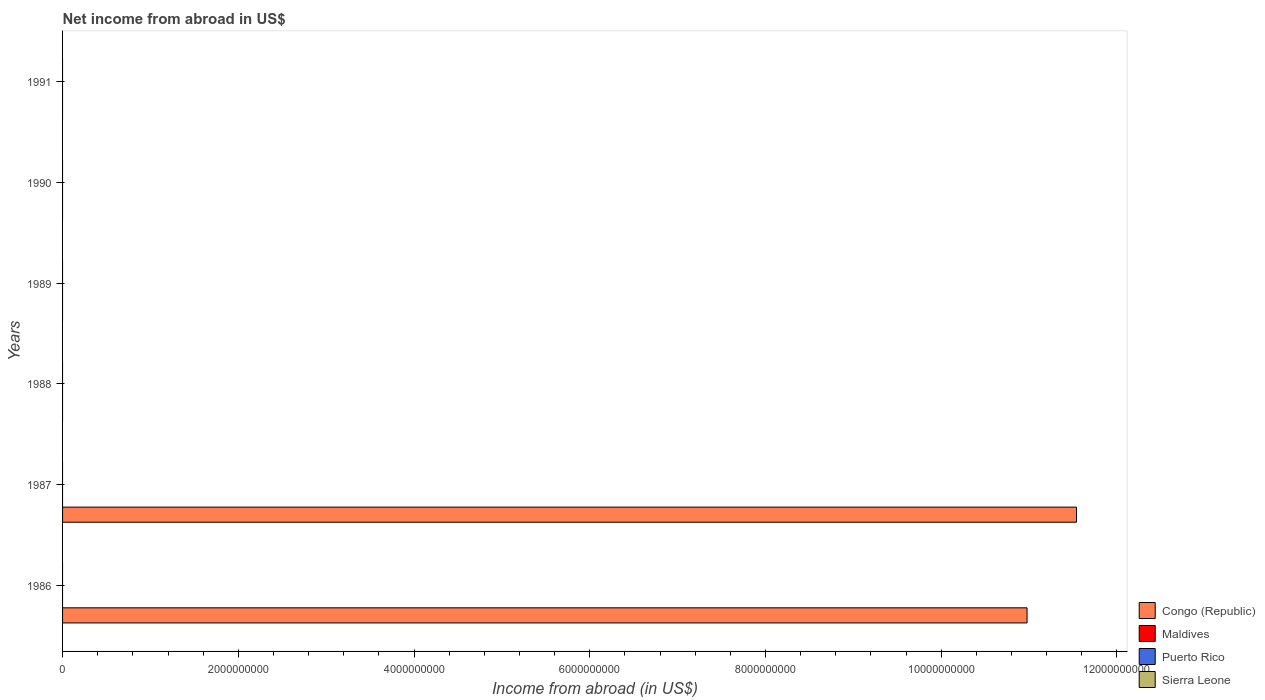Are the number of bars per tick equal to the number of legend labels?
Offer a very short reply. No. Are the number of bars on each tick of the Y-axis equal?
Make the answer very short. No. What is the label of the 5th group of bars from the top?
Provide a succinct answer. 1987. In how many cases, is the number of bars for a given year not equal to the number of legend labels?
Give a very brief answer. 6. Across all years, what is the maximum net income from abroad in Congo (Republic)?
Give a very brief answer. 1.15e+1. In which year was the net income from abroad in Congo (Republic) maximum?
Your response must be concise. 1987. What is the difference between the highest and the lowest net income from abroad in Congo (Republic)?
Keep it short and to the point. 1.15e+1. Is it the case that in every year, the sum of the net income from abroad in Puerto Rico and net income from abroad in Maldives is greater than the sum of net income from abroad in Congo (Republic) and net income from abroad in Sierra Leone?
Make the answer very short. No. Are the values on the major ticks of X-axis written in scientific E-notation?
Offer a very short reply. No. Does the graph contain any zero values?
Ensure brevity in your answer.  Yes. Does the graph contain grids?
Your answer should be compact. No. Where does the legend appear in the graph?
Your answer should be very brief. Bottom right. What is the title of the graph?
Give a very brief answer. Net income from abroad in US$. What is the label or title of the X-axis?
Give a very brief answer. Income from abroad (in US$). What is the Income from abroad (in US$) in Congo (Republic) in 1986?
Your response must be concise. 1.10e+1. What is the Income from abroad (in US$) of Puerto Rico in 1986?
Your response must be concise. 0. What is the Income from abroad (in US$) of Congo (Republic) in 1987?
Offer a terse response. 1.15e+1. What is the Income from abroad (in US$) in Sierra Leone in 1987?
Give a very brief answer. 0. What is the Income from abroad (in US$) of Maldives in 1988?
Your response must be concise. 0. What is the Income from abroad (in US$) of Puerto Rico in 1988?
Keep it short and to the point. 0. What is the Income from abroad (in US$) in Maldives in 1990?
Your answer should be compact. 0. What is the Income from abroad (in US$) in Puerto Rico in 1991?
Ensure brevity in your answer.  0. What is the Income from abroad (in US$) in Sierra Leone in 1991?
Your response must be concise. 0. Across all years, what is the maximum Income from abroad (in US$) of Congo (Republic)?
Your answer should be very brief. 1.15e+1. What is the total Income from abroad (in US$) in Congo (Republic) in the graph?
Your answer should be compact. 2.25e+1. What is the total Income from abroad (in US$) of Puerto Rico in the graph?
Keep it short and to the point. 0. What is the difference between the Income from abroad (in US$) in Congo (Republic) in 1986 and that in 1987?
Offer a terse response. -5.63e+08. What is the average Income from abroad (in US$) in Congo (Republic) per year?
Your answer should be very brief. 3.75e+09. What is the ratio of the Income from abroad (in US$) of Congo (Republic) in 1986 to that in 1987?
Ensure brevity in your answer.  0.95. What is the difference between the highest and the lowest Income from abroad (in US$) of Congo (Republic)?
Your response must be concise. 1.15e+1. 